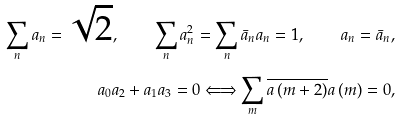<formula> <loc_0><loc_0><loc_500><loc_500>\sum _ { n } a _ { n } = \sqrt { 2 } , \quad \sum _ { n } a _ { n } ^ { 2 } = \sum _ { n } \bar { a } _ { n } a _ { n } = 1 , \quad a _ { n } = \bar { a } _ { n } , \\ a _ { 0 } a _ { 2 } + a _ { 1 } a _ { 3 } = 0 \Longleftrightarrow \sum _ { m } \overline { a \left ( m + 2 \right ) } a \left ( m \right ) = 0 ,</formula> 